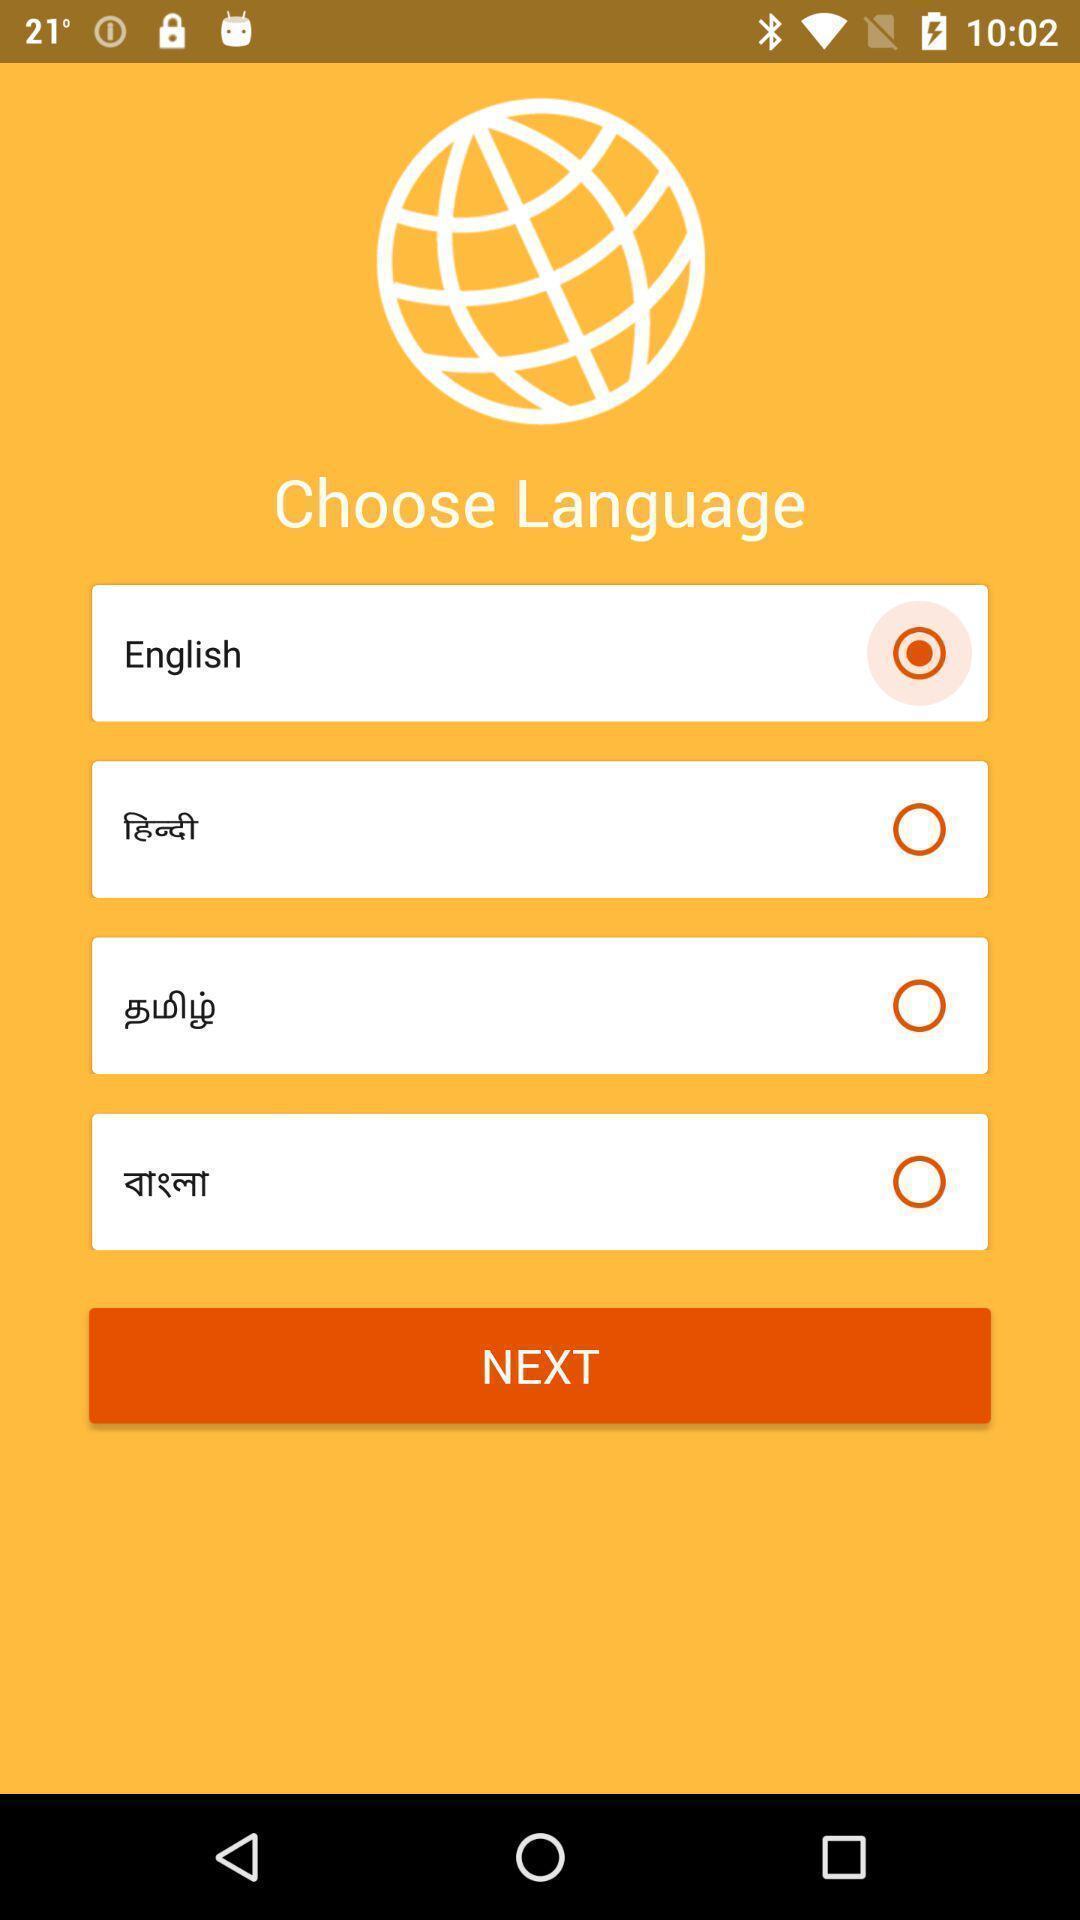Summarize the information in this screenshot. Screen displaying list of languages to choose. 